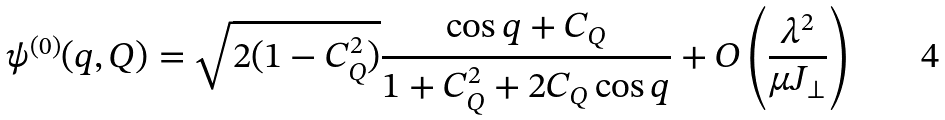<formula> <loc_0><loc_0><loc_500><loc_500>\psi ^ { ( 0 ) } ( q , Q ) = \sqrt { 2 ( 1 - C _ { Q } ^ { 2 } ) } \frac { \cos q + C _ { Q } } { 1 + C _ { Q } ^ { 2 } + 2 C _ { Q } \cos q } + O \left ( \frac { \lambda ^ { 2 } } { \mu J _ { \perp } } \right )</formula> 